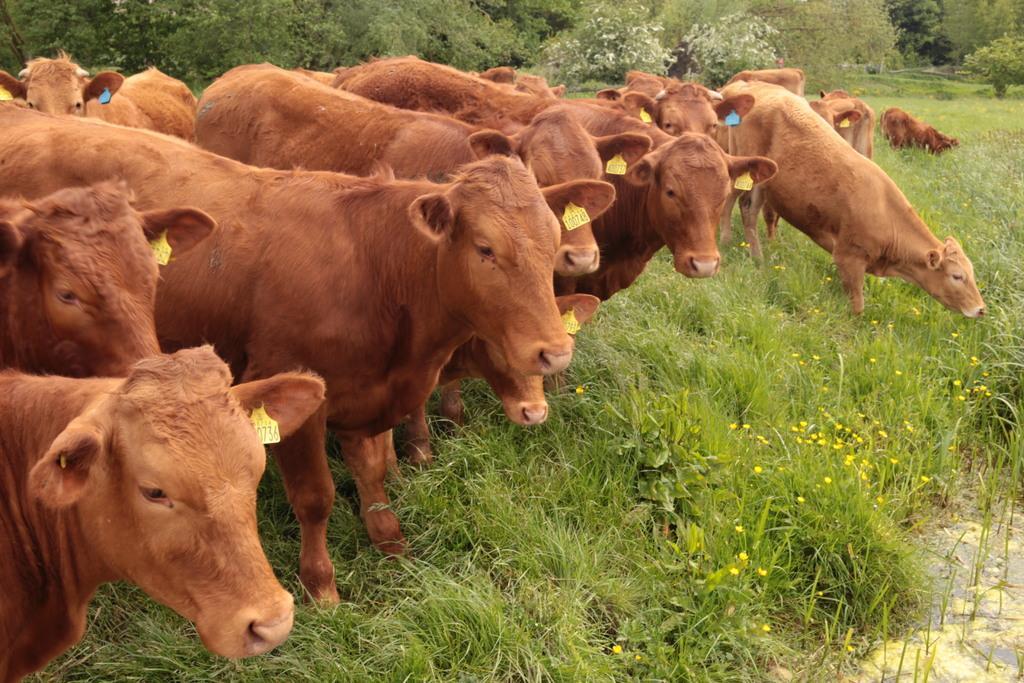In one or two sentences, can you explain what this image depicts? In this image I can see few animals, they are in brown color. Background I can see grass and trees in green color. 